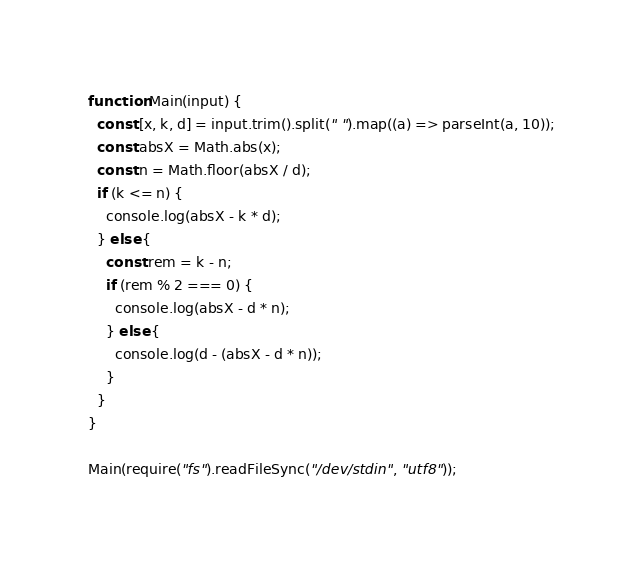Convert code to text. <code><loc_0><loc_0><loc_500><loc_500><_JavaScript_>function Main(input) {
  const [x, k, d] = input.trim().split(" ").map((a) => parseInt(a, 10));
  const absX = Math.abs(x);
  const n = Math.floor(absX / d);
  if (k <= n) {
    console.log(absX - k * d);
  } else {
    const rem = k - n;
    if (rem % 2 === 0) {
      console.log(absX - d * n);
    } else {
      console.log(d - (absX - d * n));
    }
  }
}
 
Main(require("fs").readFileSync("/dev/stdin", "utf8"));</code> 